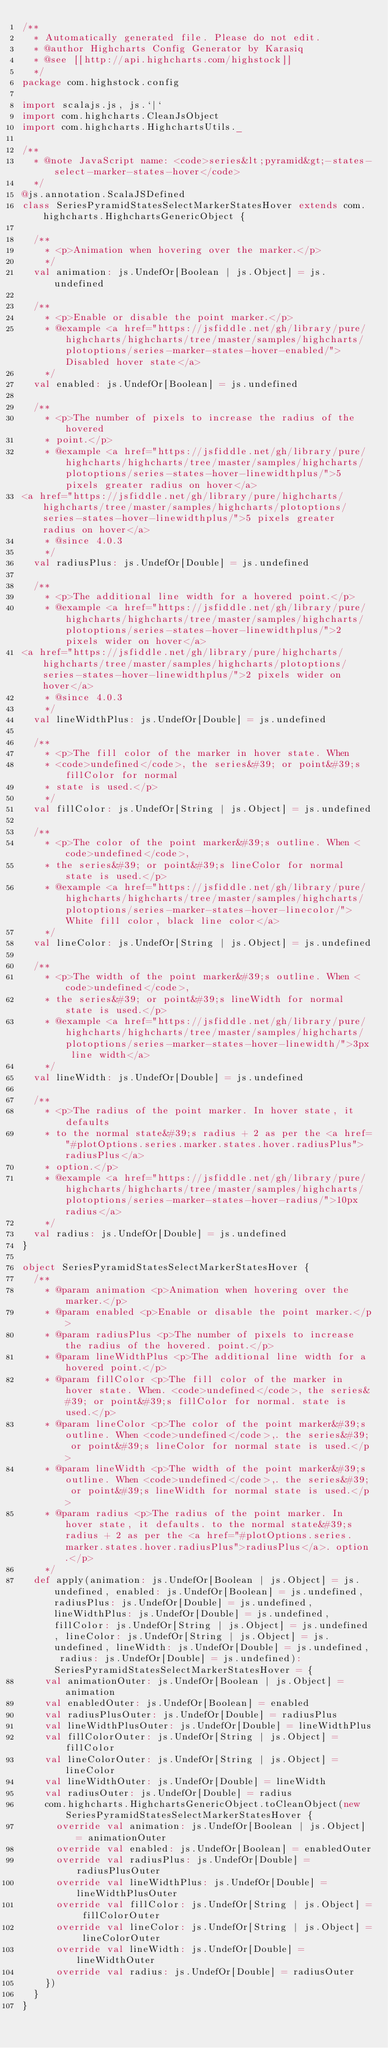<code> <loc_0><loc_0><loc_500><loc_500><_Scala_>/**
  * Automatically generated file. Please do not edit.
  * @author Highcharts Config Generator by Karasiq
  * @see [[http://api.highcharts.com/highstock]]
  */
package com.highstock.config

import scalajs.js, js.`|`
import com.highcharts.CleanJsObject
import com.highcharts.HighchartsUtils._

/**
  * @note JavaScript name: <code>series&lt;pyramid&gt;-states-select-marker-states-hover</code>
  */
@js.annotation.ScalaJSDefined
class SeriesPyramidStatesSelectMarkerStatesHover extends com.highcharts.HighchartsGenericObject {

  /**
    * <p>Animation when hovering over the marker.</p>
    */
  val animation: js.UndefOr[Boolean | js.Object] = js.undefined

  /**
    * <p>Enable or disable the point marker.</p>
    * @example <a href="https://jsfiddle.net/gh/library/pure/highcharts/highcharts/tree/master/samples/highcharts/plotoptions/series-marker-states-hover-enabled/">Disabled hover state</a>
    */
  val enabled: js.UndefOr[Boolean] = js.undefined

  /**
    * <p>The number of pixels to increase the radius of the hovered
    * point.</p>
    * @example <a href="https://jsfiddle.net/gh/library/pure/highcharts/highcharts/tree/master/samples/highcharts/plotoptions/series-states-hover-linewidthplus/">5 pixels greater radius on hover</a>
<a href="https://jsfiddle.net/gh/library/pure/highcharts/highcharts/tree/master/samples/highcharts/plotoptions/series-states-hover-linewidthplus/">5 pixels greater radius on hover</a>
    * @since 4.0.3
    */
  val radiusPlus: js.UndefOr[Double] = js.undefined

  /**
    * <p>The additional line width for a hovered point.</p>
    * @example <a href="https://jsfiddle.net/gh/library/pure/highcharts/highcharts/tree/master/samples/highcharts/plotoptions/series-states-hover-linewidthplus/">2 pixels wider on hover</a>
<a href="https://jsfiddle.net/gh/library/pure/highcharts/highcharts/tree/master/samples/highcharts/plotoptions/series-states-hover-linewidthplus/">2 pixels wider on hover</a>
    * @since 4.0.3
    */
  val lineWidthPlus: js.UndefOr[Double] = js.undefined

  /**
    * <p>The fill color of the marker in hover state. When
    * <code>undefined</code>, the series&#39; or point&#39;s fillColor for normal
    * state is used.</p>
    */
  val fillColor: js.UndefOr[String | js.Object] = js.undefined

  /**
    * <p>The color of the point marker&#39;s outline. When <code>undefined</code>,
    * the series&#39; or point&#39;s lineColor for normal state is used.</p>
    * @example <a href="https://jsfiddle.net/gh/library/pure/highcharts/highcharts/tree/master/samples/highcharts/plotoptions/series-marker-states-hover-linecolor/">White fill color, black line color</a>
    */
  val lineColor: js.UndefOr[String | js.Object] = js.undefined

  /**
    * <p>The width of the point marker&#39;s outline. When <code>undefined</code>,
    * the series&#39; or point&#39;s lineWidth for normal state is used.</p>
    * @example <a href="https://jsfiddle.net/gh/library/pure/highcharts/highcharts/tree/master/samples/highcharts/plotoptions/series-marker-states-hover-linewidth/">3px line width</a>
    */
  val lineWidth: js.UndefOr[Double] = js.undefined

  /**
    * <p>The radius of the point marker. In hover state, it defaults
    * to the normal state&#39;s radius + 2 as per the <a href="#plotOptions.series.marker.states.hover.radiusPlus">radiusPlus</a>
    * option.</p>
    * @example <a href="https://jsfiddle.net/gh/library/pure/highcharts/highcharts/tree/master/samples/highcharts/plotoptions/series-marker-states-hover-radius/">10px radius</a>
    */
  val radius: js.UndefOr[Double] = js.undefined
}

object SeriesPyramidStatesSelectMarkerStatesHover {
  /**
    * @param animation <p>Animation when hovering over the marker.</p>
    * @param enabled <p>Enable or disable the point marker.</p>
    * @param radiusPlus <p>The number of pixels to increase the radius of the hovered. point.</p>
    * @param lineWidthPlus <p>The additional line width for a hovered point.</p>
    * @param fillColor <p>The fill color of the marker in hover state. When. <code>undefined</code>, the series&#39; or point&#39;s fillColor for normal. state is used.</p>
    * @param lineColor <p>The color of the point marker&#39;s outline. When <code>undefined</code>,. the series&#39; or point&#39;s lineColor for normal state is used.</p>
    * @param lineWidth <p>The width of the point marker&#39;s outline. When <code>undefined</code>,. the series&#39; or point&#39;s lineWidth for normal state is used.</p>
    * @param radius <p>The radius of the point marker. In hover state, it defaults. to the normal state&#39;s radius + 2 as per the <a href="#plotOptions.series.marker.states.hover.radiusPlus">radiusPlus</a>. option.</p>
    */
  def apply(animation: js.UndefOr[Boolean | js.Object] = js.undefined, enabled: js.UndefOr[Boolean] = js.undefined, radiusPlus: js.UndefOr[Double] = js.undefined, lineWidthPlus: js.UndefOr[Double] = js.undefined, fillColor: js.UndefOr[String | js.Object] = js.undefined, lineColor: js.UndefOr[String | js.Object] = js.undefined, lineWidth: js.UndefOr[Double] = js.undefined, radius: js.UndefOr[Double] = js.undefined): SeriesPyramidStatesSelectMarkerStatesHover = {
    val animationOuter: js.UndefOr[Boolean | js.Object] = animation
    val enabledOuter: js.UndefOr[Boolean] = enabled
    val radiusPlusOuter: js.UndefOr[Double] = radiusPlus
    val lineWidthPlusOuter: js.UndefOr[Double] = lineWidthPlus
    val fillColorOuter: js.UndefOr[String | js.Object] = fillColor
    val lineColorOuter: js.UndefOr[String | js.Object] = lineColor
    val lineWidthOuter: js.UndefOr[Double] = lineWidth
    val radiusOuter: js.UndefOr[Double] = radius
    com.highcharts.HighchartsGenericObject.toCleanObject(new SeriesPyramidStatesSelectMarkerStatesHover {
      override val animation: js.UndefOr[Boolean | js.Object] = animationOuter
      override val enabled: js.UndefOr[Boolean] = enabledOuter
      override val radiusPlus: js.UndefOr[Double] = radiusPlusOuter
      override val lineWidthPlus: js.UndefOr[Double] = lineWidthPlusOuter
      override val fillColor: js.UndefOr[String | js.Object] = fillColorOuter
      override val lineColor: js.UndefOr[String | js.Object] = lineColorOuter
      override val lineWidth: js.UndefOr[Double] = lineWidthOuter
      override val radius: js.UndefOr[Double] = radiusOuter
    })
  }
}
</code> 